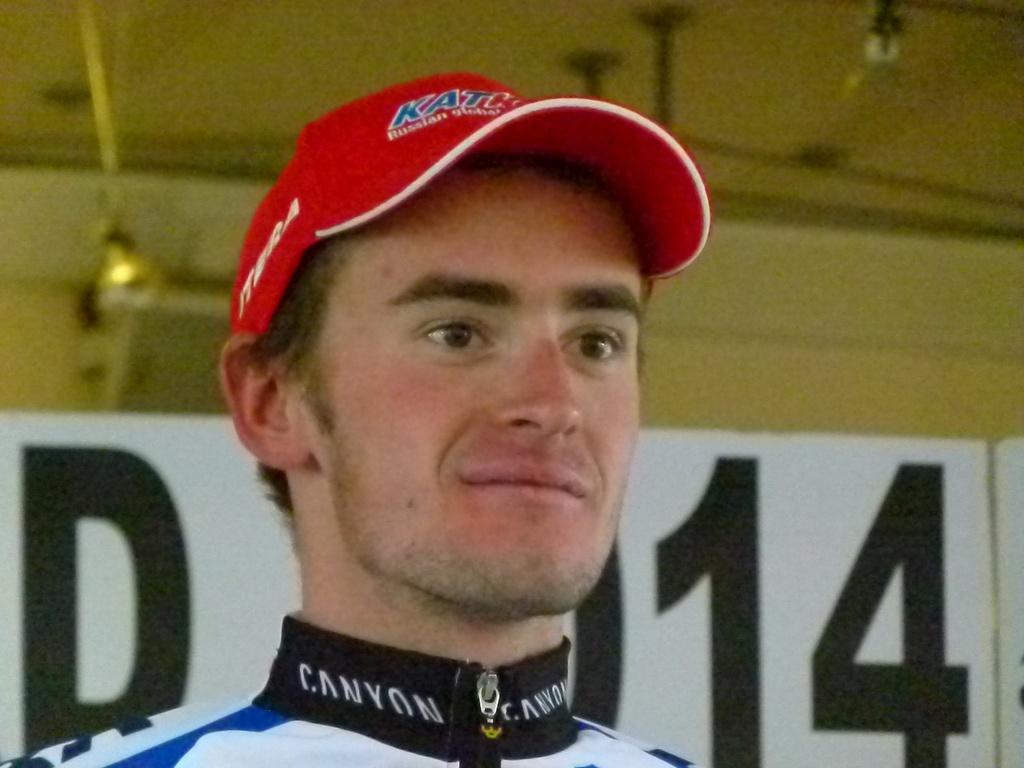How would you summarize this image in a sentence or two? In front of the image there is a person wearing a cap. Behind him there is a board with some letters on it. In the background of the image there is a wall. There are lights. 